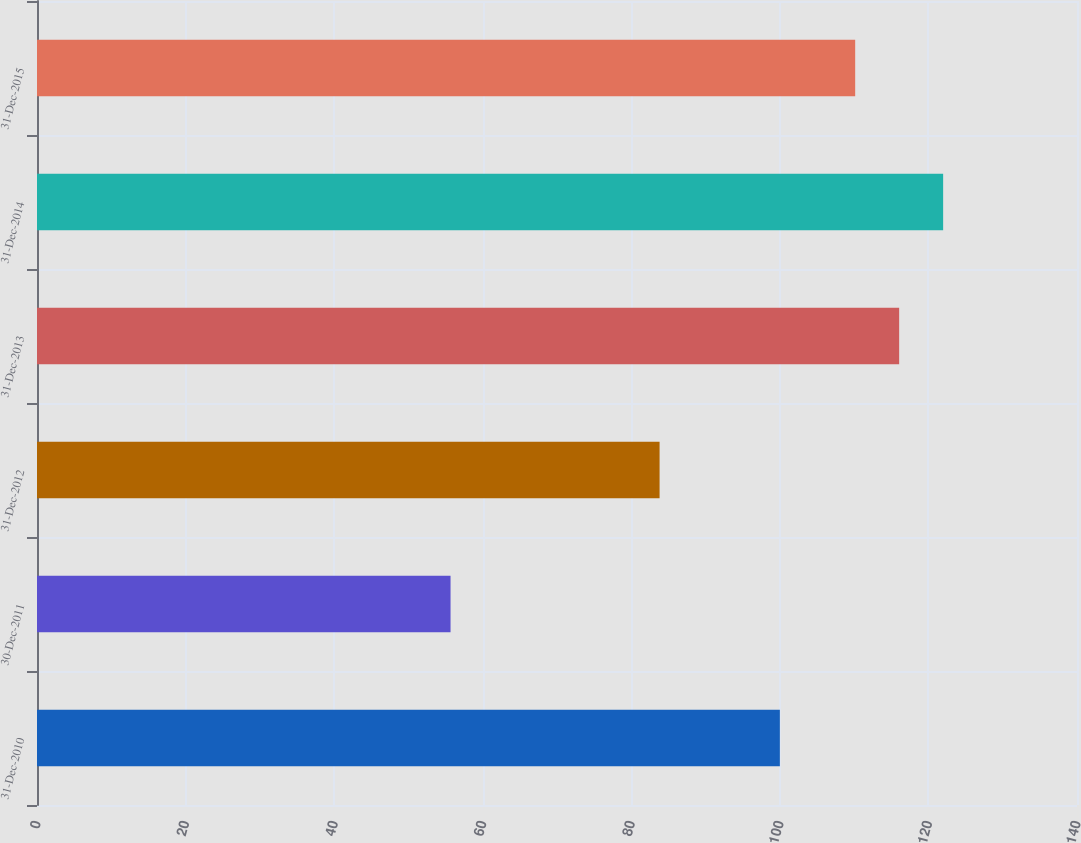Convert chart to OTSL. <chart><loc_0><loc_0><loc_500><loc_500><bar_chart><fcel>31-Dec-2010<fcel>30-Dec-2011<fcel>31-Dec-2012<fcel>31-Dec-2013<fcel>31-Dec-2014<fcel>31-Dec-2015<nl><fcel>100<fcel>55.67<fcel>83.81<fcel>116.06<fcel>121.98<fcel>110.14<nl></chart> 